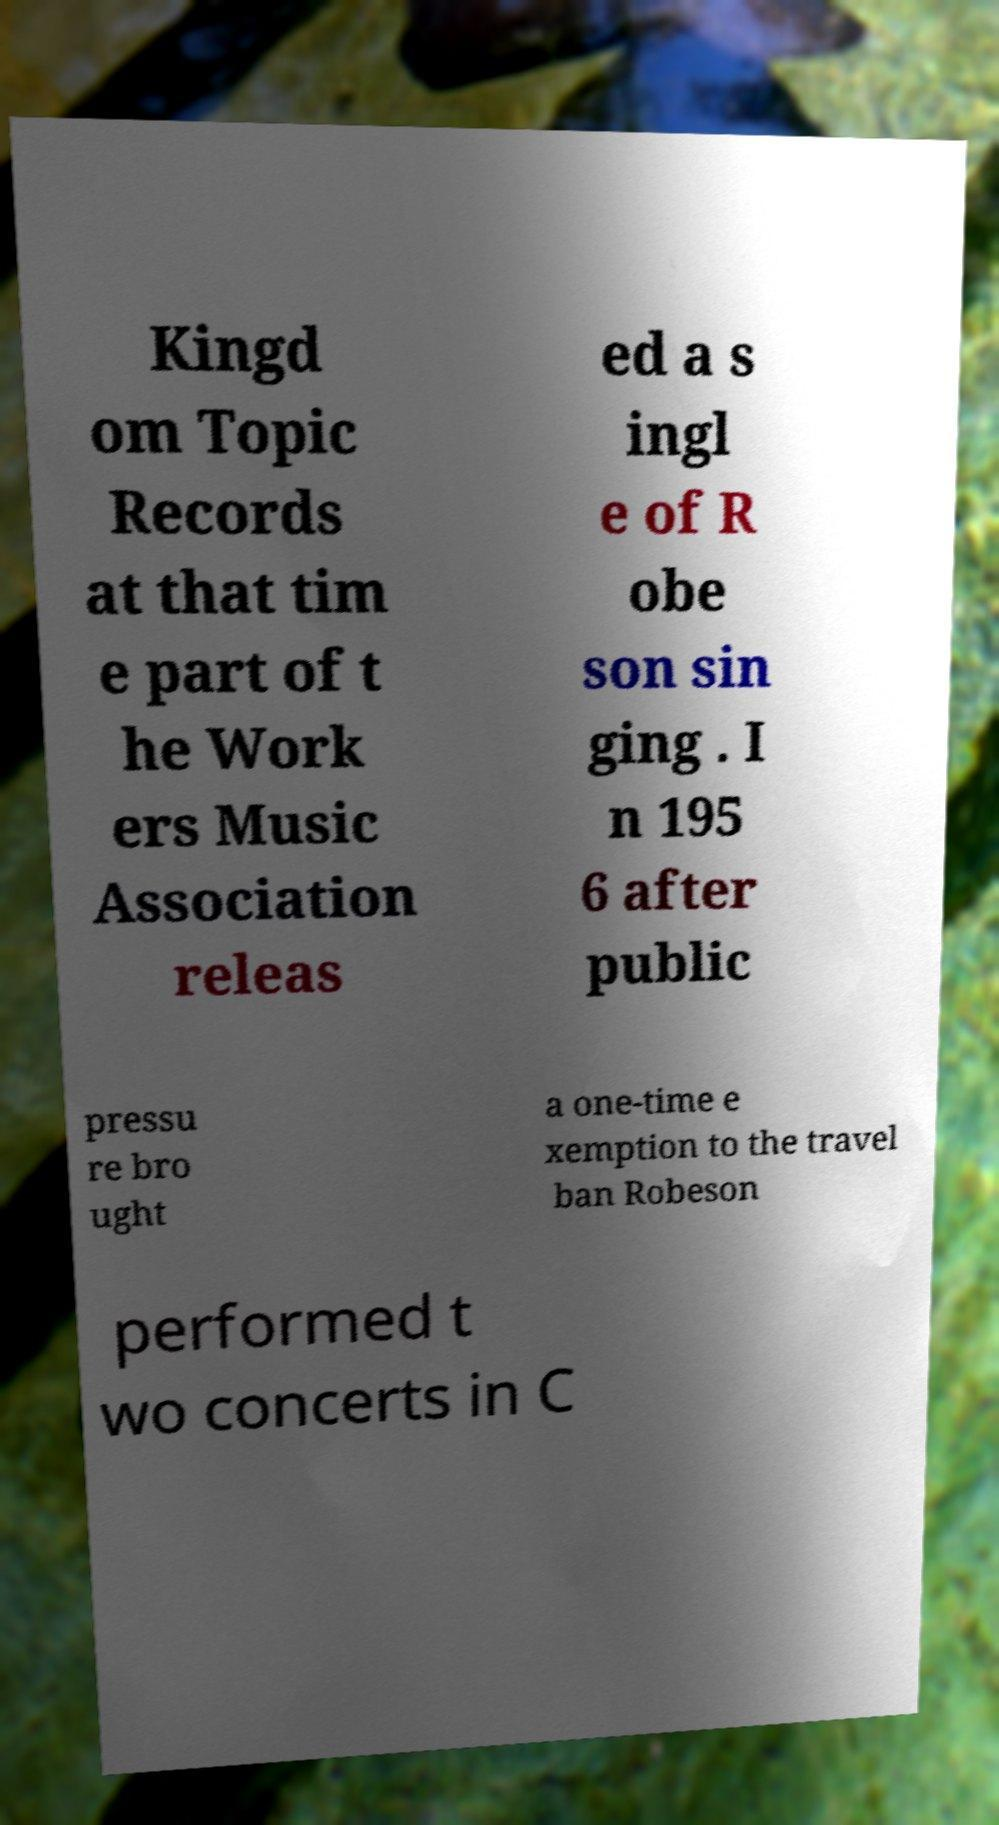I need the written content from this picture converted into text. Can you do that? Kingd om Topic Records at that tim e part of t he Work ers Music Association releas ed a s ingl e of R obe son sin ging . I n 195 6 after public pressu re bro ught a one-time e xemption to the travel ban Robeson performed t wo concerts in C 